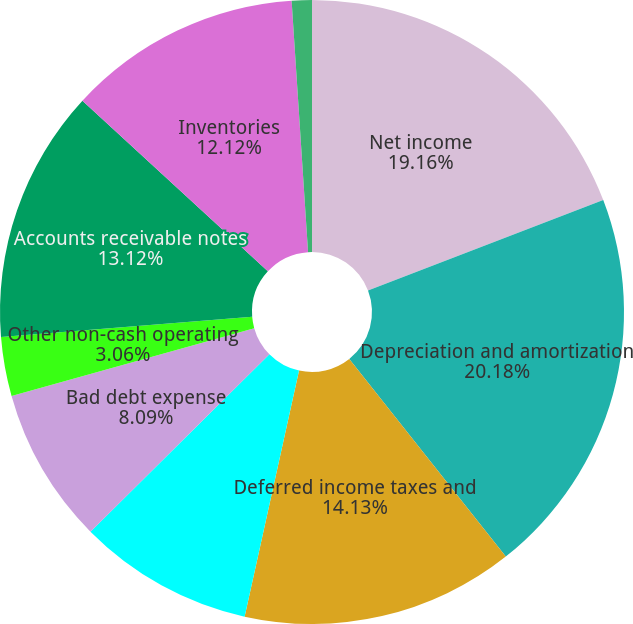<chart> <loc_0><loc_0><loc_500><loc_500><pie_chart><fcel>Net income<fcel>Depreciation and amortization<fcel>Deferred income taxes and<fcel>Postretirement benefits<fcel>Bad debt expense<fcel>Other non-cash operating<fcel>Accounts receivable notes<fcel>Inventories<fcel>Accounts payable<nl><fcel>19.16%<fcel>20.17%<fcel>14.13%<fcel>9.1%<fcel>8.09%<fcel>3.06%<fcel>13.12%<fcel>12.12%<fcel>1.04%<nl></chart> 